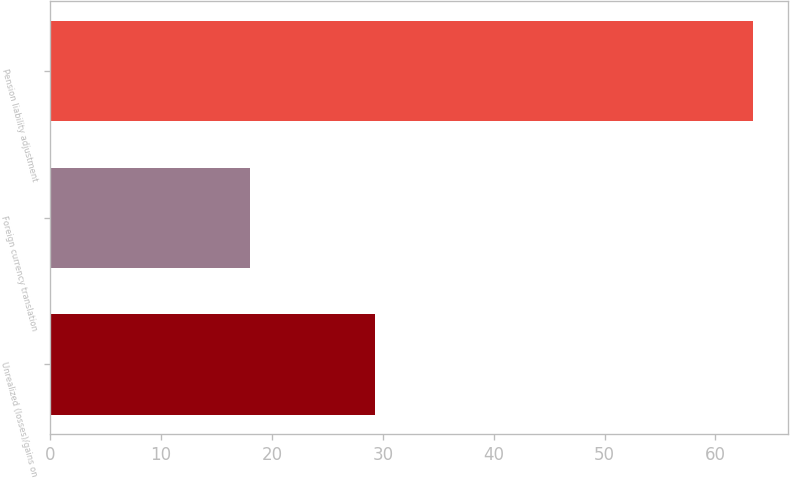Convert chart. <chart><loc_0><loc_0><loc_500><loc_500><bar_chart><fcel>Unrealized (losses)/gains on<fcel>Foreign currency translation<fcel>Pension liability adjustment<nl><fcel>29.3<fcel>18<fcel>63.4<nl></chart> 